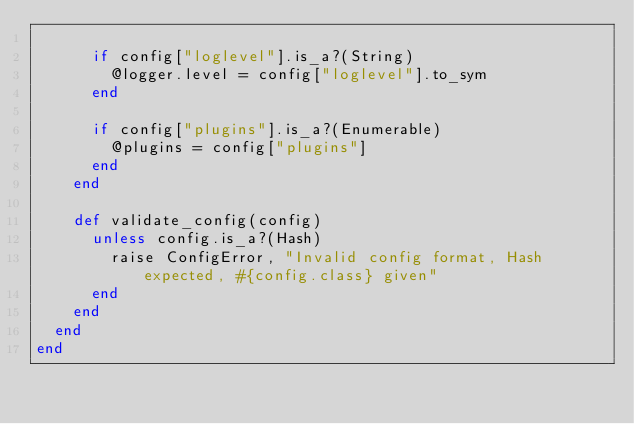Convert code to text. <code><loc_0><loc_0><loc_500><loc_500><_Ruby_>
      if config["loglevel"].is_a?(String)
        @logger.level = config["loglevel"].to_sym
      end

      if config["plugins"].is_a?(Enumerable)
        @plugins = config["plugins"]
      end
    end

    def validate_config(config)
      unless config.is_a?(Hash)
        raise ConfigError, "Invalid config format, Hash expected, #{config.class} given"
      end
    end
  end
end
</code> 